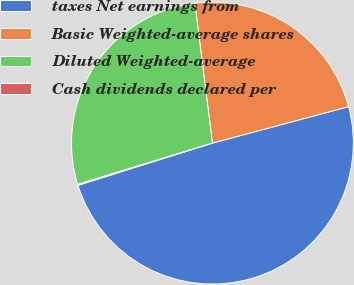Convert chart to OTSL. <chart><loc_0><loc_0><loc_500><loc_500><pie_chart><fcel>taxes Net earnings from<fcel>Basic Weighted-average shares<fcel>Diluted Weighted-average<fcel>Cash dividends declared per<nl><fcel>49.32%<fcel>22.82%<fcel>27.74%<fcel>0.11%<nl></chart> 